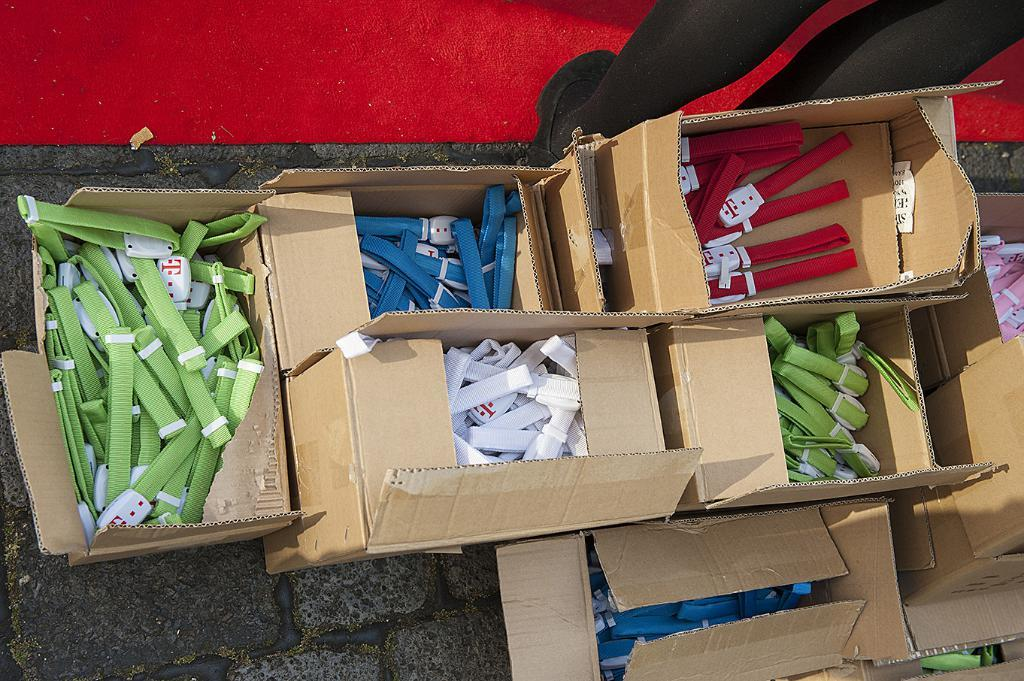What is inside the boxes that are visible in the image? There are belts in the boxes in the image. Where are the boxes located in the image? The boxes are placed on the road. Can you describe the person in the background of the image? There is a person standing in the background of the image. What is the person standing on in the image? The person is standing on a mat. What type of school can be seen in the image? There is no school present in the image. Can you describe the harbor in the image? There is no harbor present in the image. 